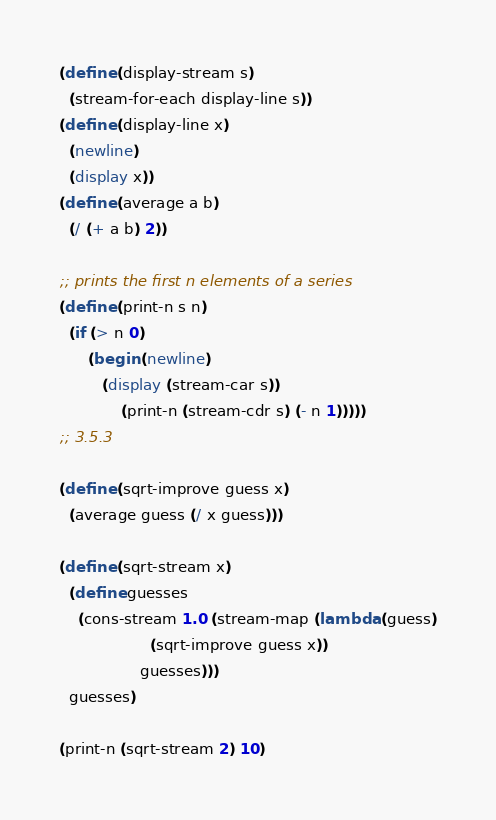<code> <loc_0><loc_0><loc_500><loc_500><_Scheme_>(define (display-stream s)
  (stream-for-each display-line s))
(define (display-line x)
  (newline)
  (display x))
(define (average a b)
  (/ (+ a b) 2))

;; prints the first n elements of a series
(define (print-n s n)
  (if (> n 0)
      (begin (newline)
	     (display (stream-car s))
             (print-n (stream-cdr s) (- n 1)))))
;; 3.5.3

(define (sqrt-improve guess x)
  (average guess (/ x guess)))

(define (sqrt-stream x)
  (define guesses
    (cons-stream 1.0 (stream-map (lambda (guess)
				   (sqrt-improve guess x))
				 guesses)))
  guesses)

(print-n (sqrt-stream 2) 10)
</code> 